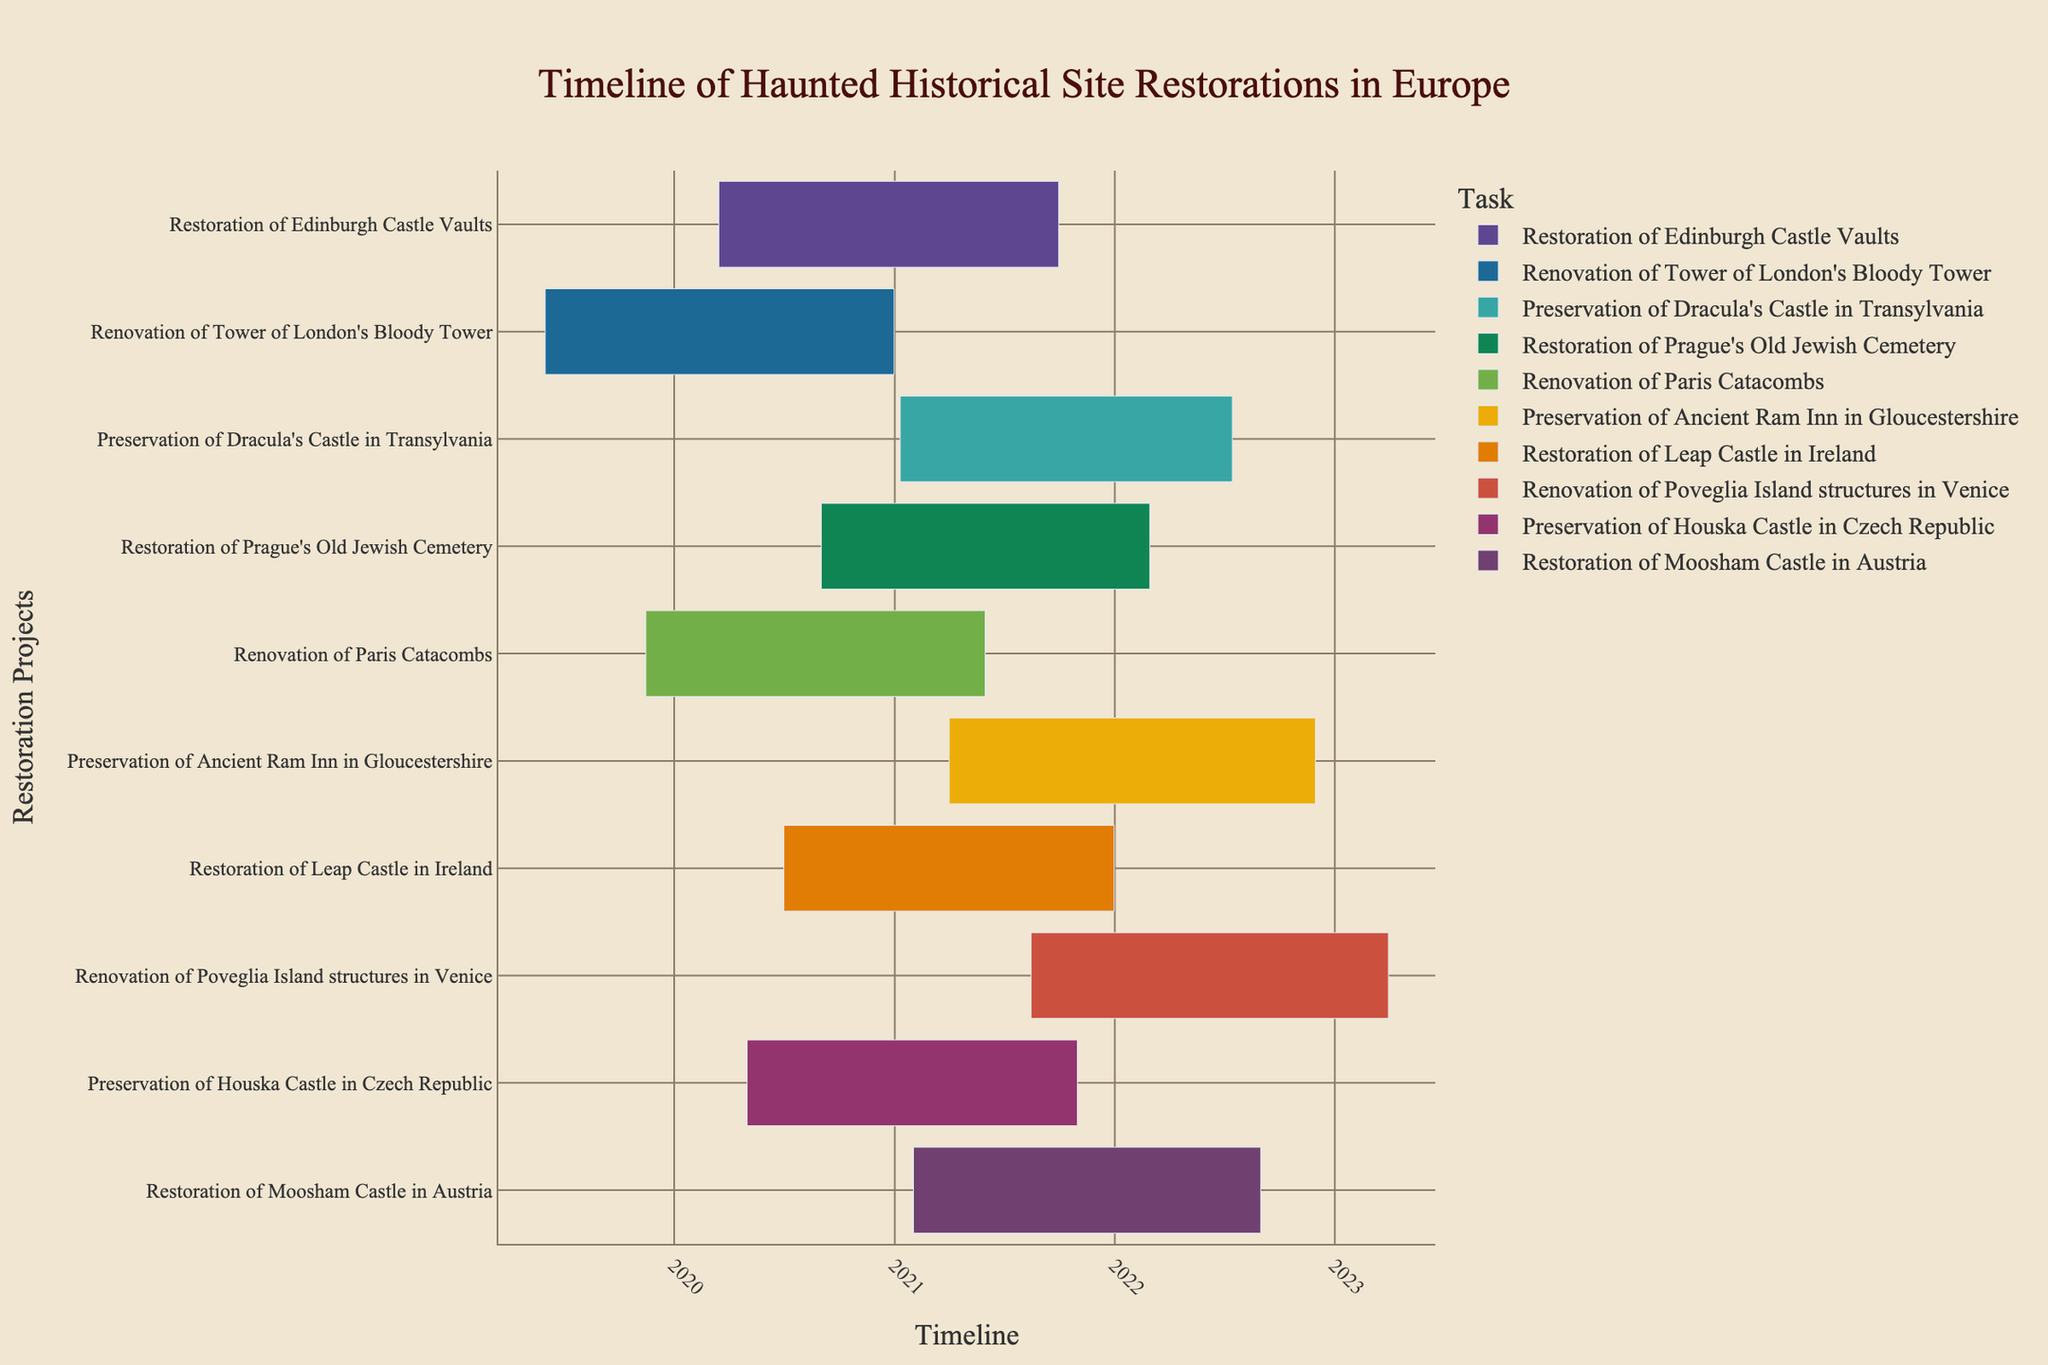Which restoration project started first? To identify which restoration project started first, look for the task with the earliest starting date on the Gantt chart.
Answer: Renovation of Tower of London's Bloody Tower What is the total duration of the Restoration of Edinburgh Castle Vaults project? First, find the start and end dates for the Restoration of Edinburgh Castle Vaults. Start: March 15, 2020, and End: September 30, 2021. Calculate the difference between these dates.
Answer: Approximately 1 year and 6 months Which project ended last? To find which project ended last, look at the end dates of all tasks and identify the latest one.
Answer: Renovation of Poveglia Island structures in Venice How many restoration projects were ongoing in July 2021? Identify all projects that include the month of July 2021 in their timeline.
Answer: Four projects Which project had the shortest duration? Compare the lengths of the durations shown for each project on the Gantt chart and find the shortest one.
Answer: Renovation of Tower of London's Bloody Tower Which project overlaps the most with the Preservation of Ancient Ram Inn in Gloucestershire? Identify the project whose timeline overlaps with the highest number of days with the Preservation of Ancient Ram Inn, which goes from April 1, 2021, to November 30, 2022.
Answer: Renovation of Poveglia Island structures in Venice How long was the overlap between the Restoration of Prague's Old Jewish Cemetery and the Preservation of Dracula's Castle in Transylvania? Find the overlapping period between the Restoration of Prague's Old Jewish Cemetery (September 1, 2020, to February 28, 2022) and the Preservation of Dracula's Castle (January 10, 2021, to July 15, 2022), and calculate the duration of this overlap.
Answer: Approximately 13 months Which projects were completed by the end of 2021? Identify all tasks with an end date on or before December 31, 2021, by checking the end dates on the chart.
Answer: Restoration of Edinburgh Castle Vaults, Renovation of Tower of London's Bloody Tower, Renovation of Paris Catacombs, Restoration of Leap Castle, Preservation of Houska Castle What is the average duration of all the projects? Calculate the duration of each project in months or days, then find the average of these durations.
Answer: Approximately 1 year and 4 months 